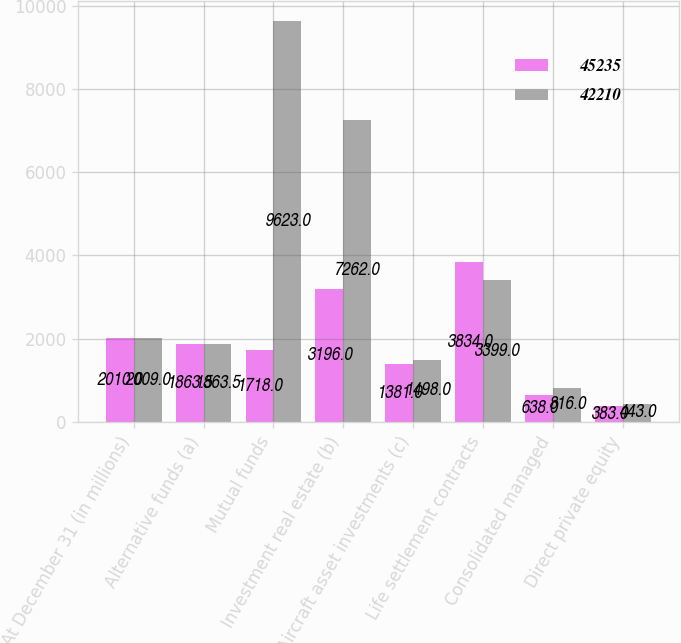Convert chart to OTSL. <chart><loc_0><loc_0><loc_500><loc_500><stacked_bar_chart><ecel><fcel>At December 31 (in millions)<fcel>Alternative funds (a)<fcel>Mutual funds<fcel>Investment real estate (b)<fcel>Aircraft asset investments (c)<fcel>Life settlement contracts<fcel>Consolidated managed<fcel>Direct private equity<nl><fcel>45235<fcel>2010<fcel>1863.5<fcel>1718<fcel>3196<fcel>1381<fcel>3834<fcel>638<fcel>383<nl><fcel>42210<fcel>2009<fcel>1863.5<fcel>9623<fcel>7262<fcel>1498<fcel>3399<fcel>816<fcel>443<nl></chart> 